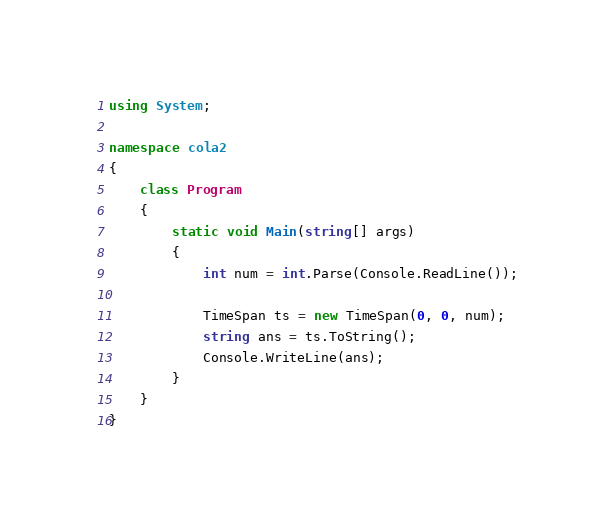Convert code to text. <code><loc_0><loc_0><loc_500><loc_500><_C#_>using System;

namespace cola2
{
    class Program
    {
        static void Main(string[] args)
        {
            int num = int.Parse(Console.ReadLine());

            TimeSpan ts = new TimeSpan(0, 0, num);
            string ans = ts.ToString();
            Console.WriteLine(ans);
        }
    }
}</code> 